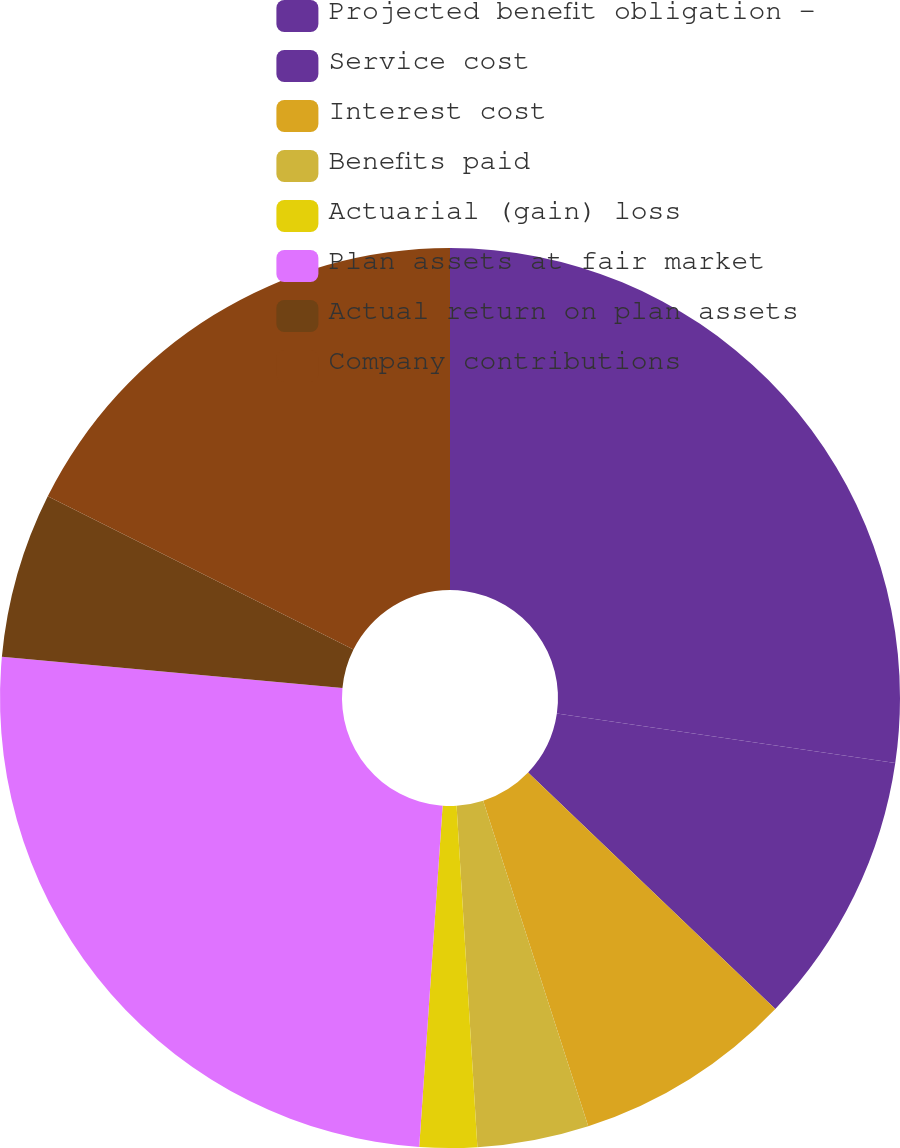Convert chart. <chart><loc_0><loc_0><loc_500><loc_500><pie_chart><fcel>Projected benefit obligation -<fcel>Service cost<fcel>Interest cost<fcel>Benefits paid<fcel>Actuarial (gain) loss<fcel>Plan assets at fair market<fcel>Actual return on plan assets<fcel>Company contributions<nl><fcel>27.31%<fcel>9.83%<fcel>7.89%<fcel>4.0%<fcel>2.06%<fcel>25.37%<fcel>5.94%<fcel>17.6%<nl></chart> 